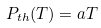Convert formula to latex. <formula><loc_0><loc_0><loc_500><loc_500>P _ { t h } ( T ) = a T</formula> 